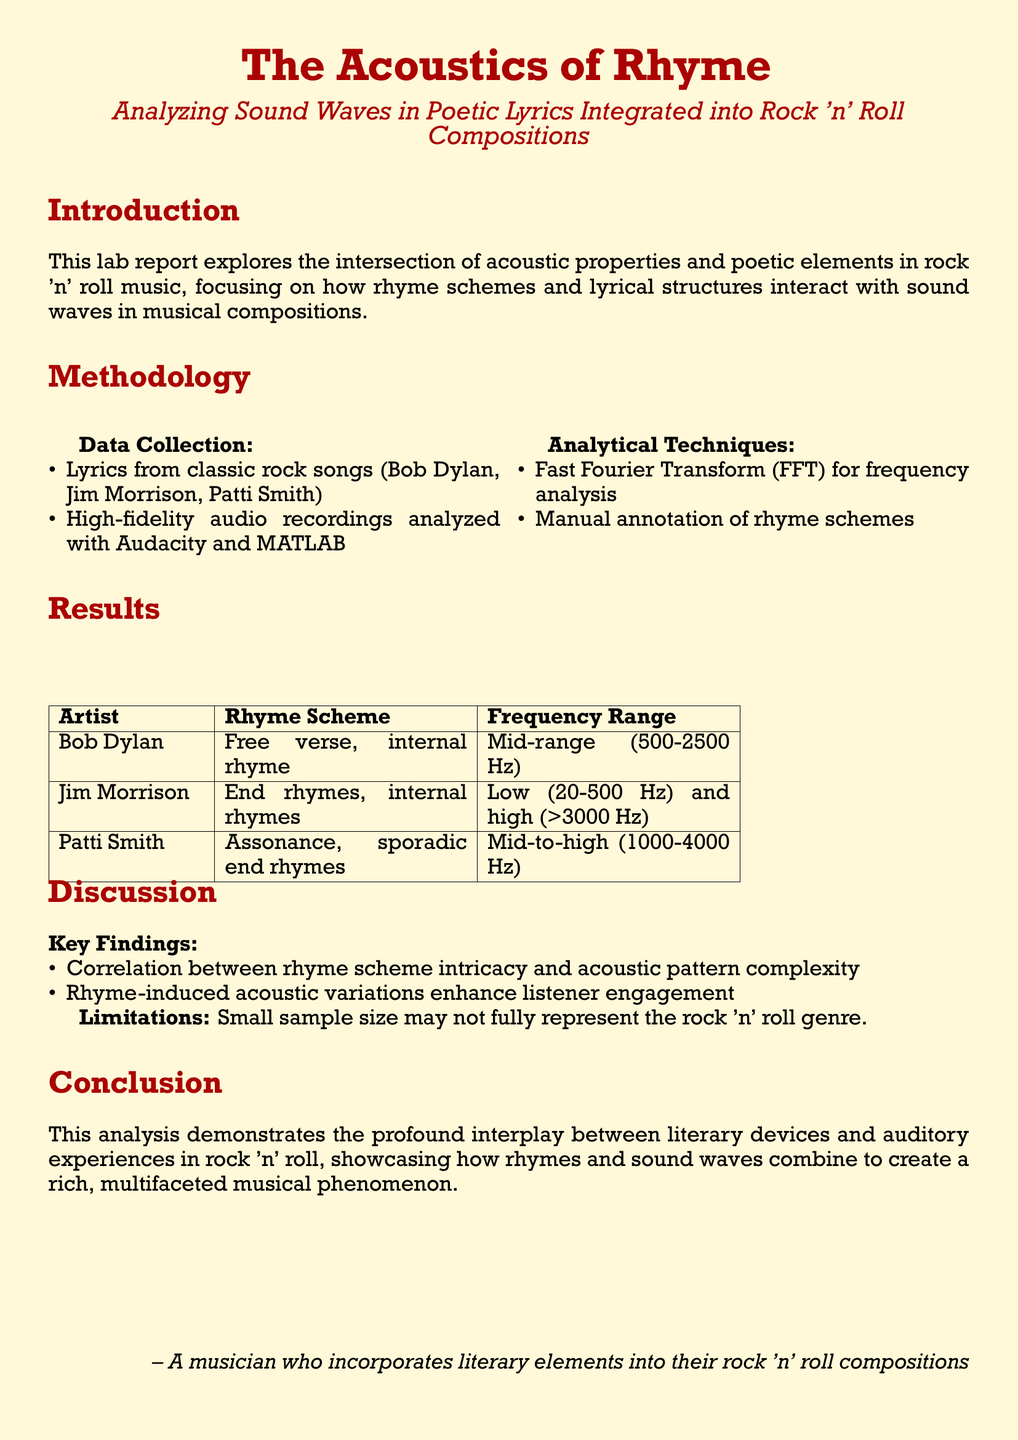What is the main focus of the study? The main focus is on the intersection of acoustic properties and poetic elements in rock 'n' roll music.
Answer: Acoustic properties and poetic elements Which artists' lyrics were analyzed? The artists include Bob Dylan, Jim Morrison, and Patti Smith.
Answer: Bob Dylan, Jim Morrison, Patti Smith What analytical technique was used for frequency analysis? Fast Fourier Transform (FFT) was used for frequency analysis.
Answer: Fast Fourier Transform (FFT) What is the rhyme scheme of Bob Dylan's lyrics? Bob Dylan's lyrics are characterized by free verse and internal rhyme.
Answer: Free verse, internal rhyme What frequency range corresponds to Jim Morrison's lyrics? Jim Morrison's lyrics have frequencies in the low range (20-500 Hz) and high range (>3000 Hz).
Answer: Low (20-500 Hz) and high (>3000 Hz) What correlation was found in the study? A correlation was found between rhyme scheme intricacy and acoustic pattern complexity.
Answer: Rhyme scheme intricacy and acoustic pattern complexity What limitation is mentioned in the report? The report mentions a small sample size as a limitation.
Answer: Small sample size What is the concluding statement's focus? The concluding statement focuses on the interplay between literary devices and auditory experiences in rock 'n' roll.
Answer: Interplay between literary devices and auditory experiences 